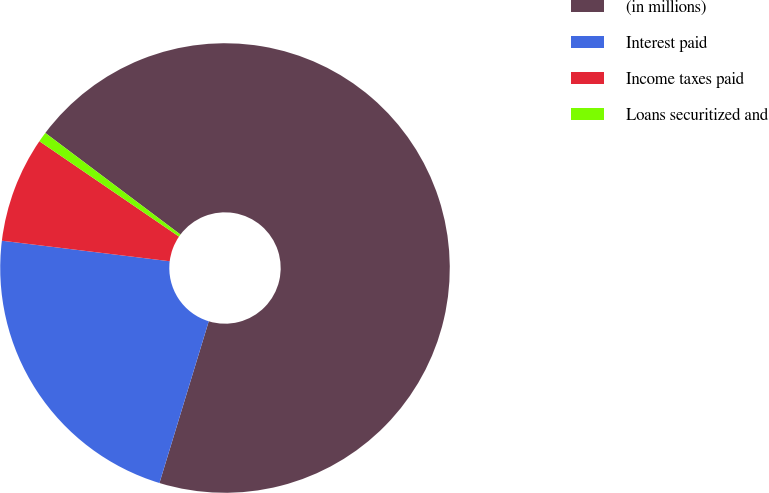Convert chart to OTSL. <chart><loc_0><loc_0><loc_500><loc_500><pie_chart><fcel>(in millions)<fcel>Interest paid<fcel>Income taxes paid<fcel>Loans securitized and<nl><fcel>69.45%<fcel>22.23%<fcel>7.6%<fcel>0.72%<nl></chart> 